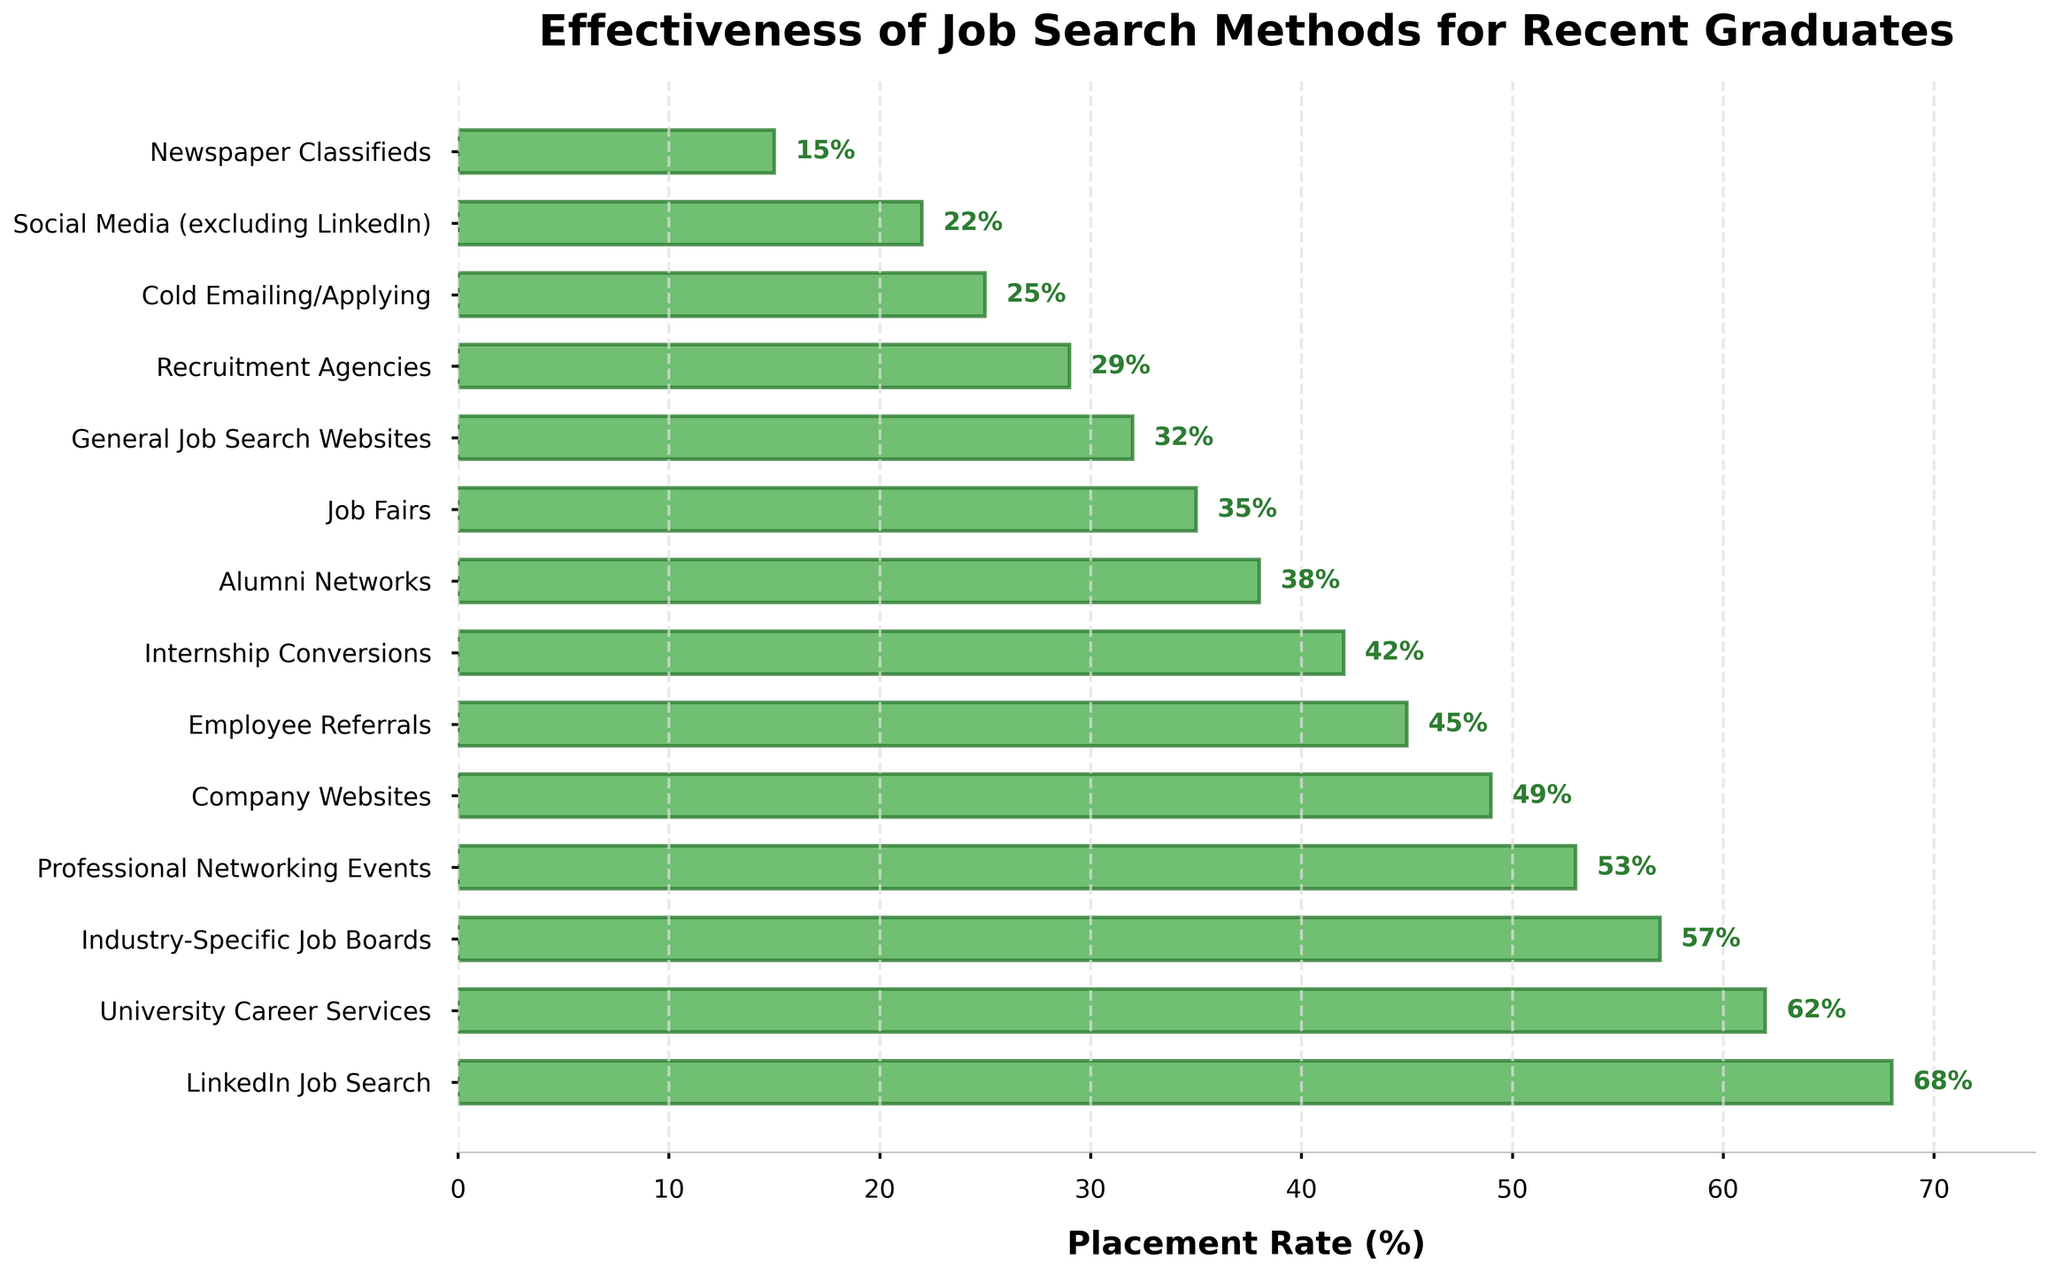What's the most effective job search method for recent graduates? The bar representing "LinkedIn Job Search" is the longest, indicating it has the highest placement rate at 68%.
Answer: LinkedIn Job Search Which job search method has a placement rate of 42%? The bar labeled "Internship Conversions" reaches the 42% mark, making it the method with a 42% placement rate.
Answer: Internship Conversions How much higher is the placement rate of University Career Services compared to Recruitment Agencies? University Career Services has a placement rate of 62%, and Recruitment Agencies have a 29% rate. The difference is 62% - 29% = 33%.
Answer: 33% What is the combined placement rate of the three least effective job search methods? The least effective methods are Newspaper Classifieds (15%), Social Media (excluding LinkedIn) (22%), and Cold Emailing/Applying (25%). Summing these gives 15% + 22% + 25% = 62%.
Answer: 62% Which methods have a placement rate lower than 50%? The methods with placement rates lower than 50% are Company Websites (49%), Employee Referrals (45%), Internship Conversions (42%), Alumni Networks (38%), Job Fairs (35%), General Job Search Websites (32%), Recruitment Agencies (29%), Cold Emailing/Applying (25%), Social Media (excluding LinkedIn) (22%), and Newspaper Classifieds (15%).
Answer: Company Websites, Employee Referrals, Internship Conversions, Alumni Networks, Job Fairs, General Job Search Websites, Recruitment Agencies, Cold Emailing/Applying, Social Media (excluding LinkedIn), Newspaper Classifieds What is the placement rate of methods that fall between the rates of Industry-Specific Job Boards and Job Fairs? Industry-Specific Job Boards have a placement rate of 57%, and Job Fairs have 35%, so the methods in between are Professional Networking Events (53%), Company Websites (49%), Employee Referrals (45%), Internship Conversions (42%), and Alumni Networks (38%). Their rates are 53%, 49%, 45%, 42%, and 38%.
Answer: Professional Networking Events, Company Websites, Employee Referrals, Internship Conversions, Alumni Networks What are the top five most effective job search methods for recent graduates? Arranging the methods by descending placement rates, the top five are LinkedIn Job Search (68%), University Career Services (62%), Industry-Specific Job Boards (57%), Professional Networking Events (53%), and Company Websites (49%).
Answer: LinkedIn Job Search, University Career Services, Industry-Specific Job Boards, Professional Networking Events, Company Websites 